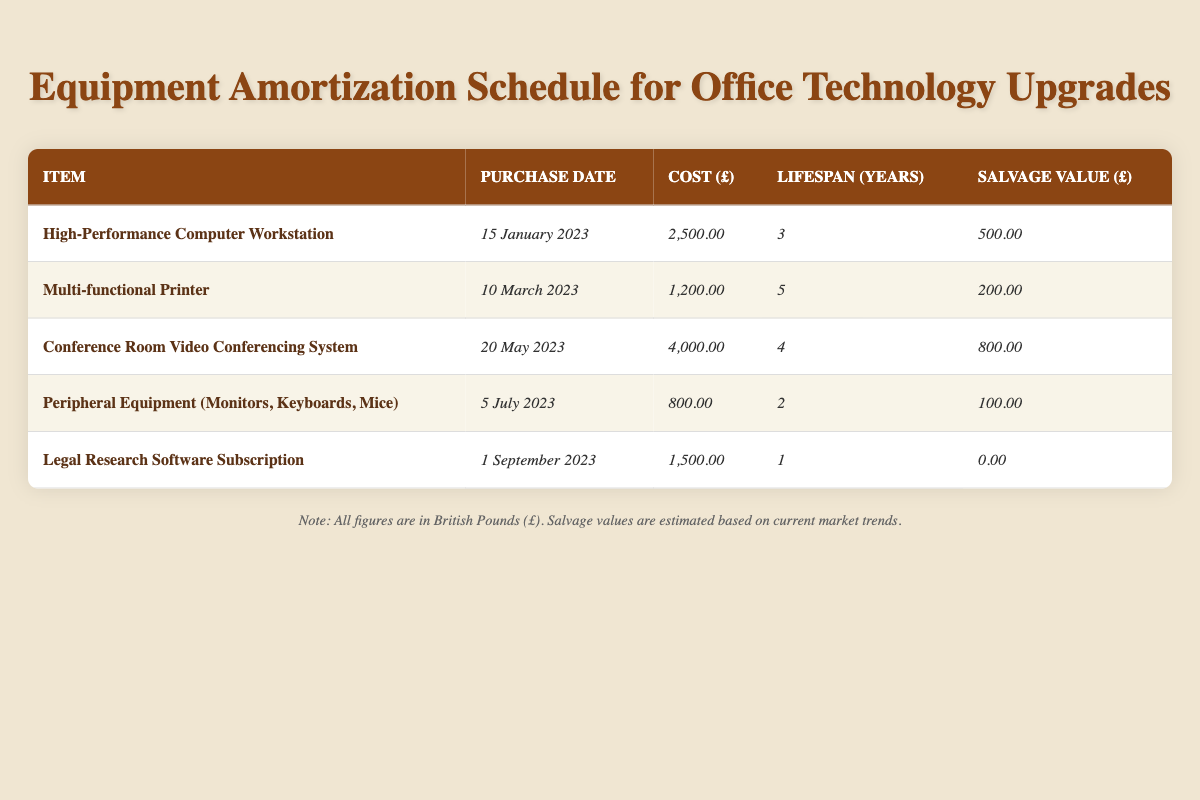What is the cost of the High-Performance Computer Workstation? According to the table, the cost is listed in the row for the High-Performance Computer Workstation, which clearly states the cost as 2500.00.
Answer: 2500.00 What is the lifespan of the Multi-functional Printer? The lifespan is found in the column for Lifespan (Years) in the row corresponding to the Multi-functional Printer, which indicates a lifespan of 5 years.
Answer: 5 years Is the salvage value of the Peripheral Equipment greater than 100? The salvage value for the Peripheral Equipment is stated as 100. Since it is not greater than 100, the answer is no.
Answer: No How much total cost is associated with all five items? To find the total cost, we add each item's cost together: 2500.00 + 1200.00 + 4000.00 + 800.00 + 1500.00 = 10000.00. Therefore, the total cost is 10000.00.
Answer: 10000.00 Which item has the highest salvage value? By comparing the salvage values listed for each item: 500.00, 200.00, 800.00, 100.00, and 0.00, we observe that 800.00 is the highest, corresponding to the Conference Room Video Conferencing System.
Answer: Conference Room Video Conferencing System What is the average lifespan of the equipment listed? To find the average lifespan, sum the lifespans: 3 + 5 + 4 + 2 + 1 = 15 years. There are 5 items, so divide 15 by 5 to get an average lifespan of 3 years.
Answer: 3 years Is there any equipment with a lifespan of just one year? The table lists the Legal Research Software Subscription with a lifespan of 1 year, confirming that yes, there is equipment with a lifespan of just one year.
Answer: Yes What is the total salvage value for all items? To determine the total salvage value, we add the salvage values: 500.00 + 200.00 + 800.00 + 100.00 + 0.00 = 1600.00. Therefore, the total salvage value for all items is 1600.00.
Answer: 1600.00 Which equipment has the lowest cost? By comparing the costs of each item, the Peripheral Equipment at 800.00 is the lowest cost found in the table.
Answer: Peripheral Equipment (Monitors, Keyboards, Mice) 